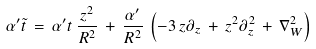<formula> <loc_0><loc_0><loc_500><loc_500>\alpha ^ { \prime } \tilde { t } \, = \, \alpha ^ { \prime } t \, \frac { z ^ { 2 } } { R ^ { 2 } } \, + \, \frac { \alpha ^ { \prime } } { R ^ { 2 } } \, \left ( - 3 \, z \partial _ { z } \, + \, z ^ { 2 } \partial ^ { 2 } _ { z } \, + \, \nabla ^ { 2 } _ { W } \right ) \,</formula> 